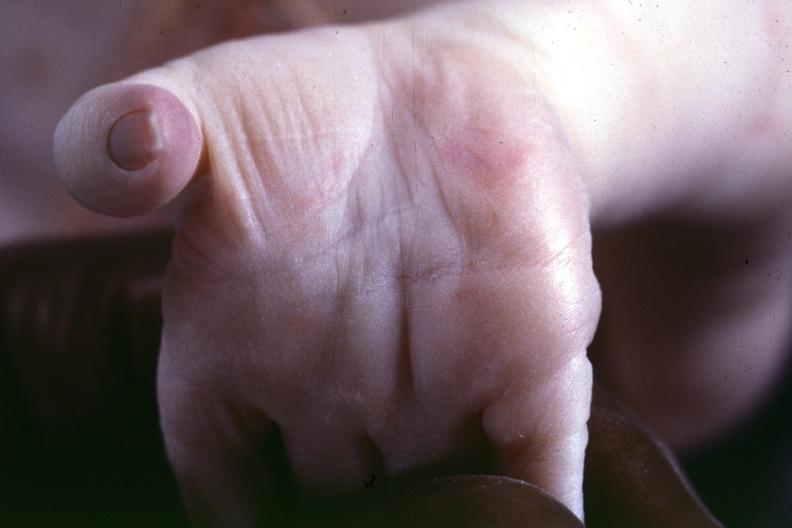was this taken from another case to illustrate the difference?
Answer the question using a single word or phrase. Yes 